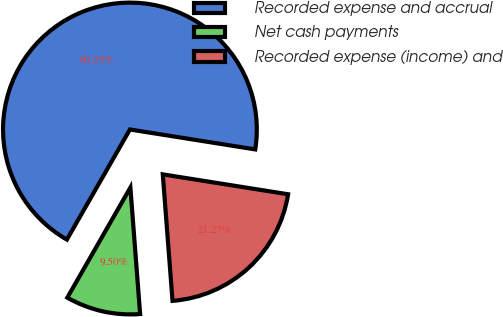<chart> <loc_0><loc_0><loc_500><loc_500><pie_chart><fcel>Recorded expense and accrual<fcel>Net cash payments<fcel>Recorded expense (income) and<nl><fcel>69.23%<fcel>9.5%<fcel>21.27%<nl></chart> 